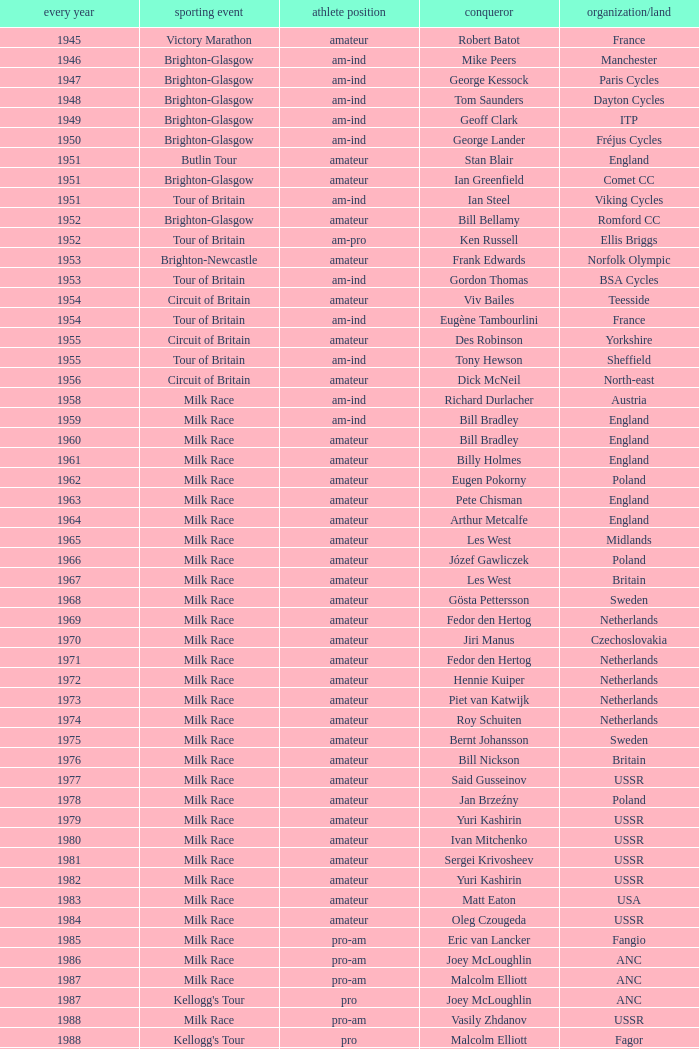What is the rider status for the 1971 netherlands team? Amateur. 